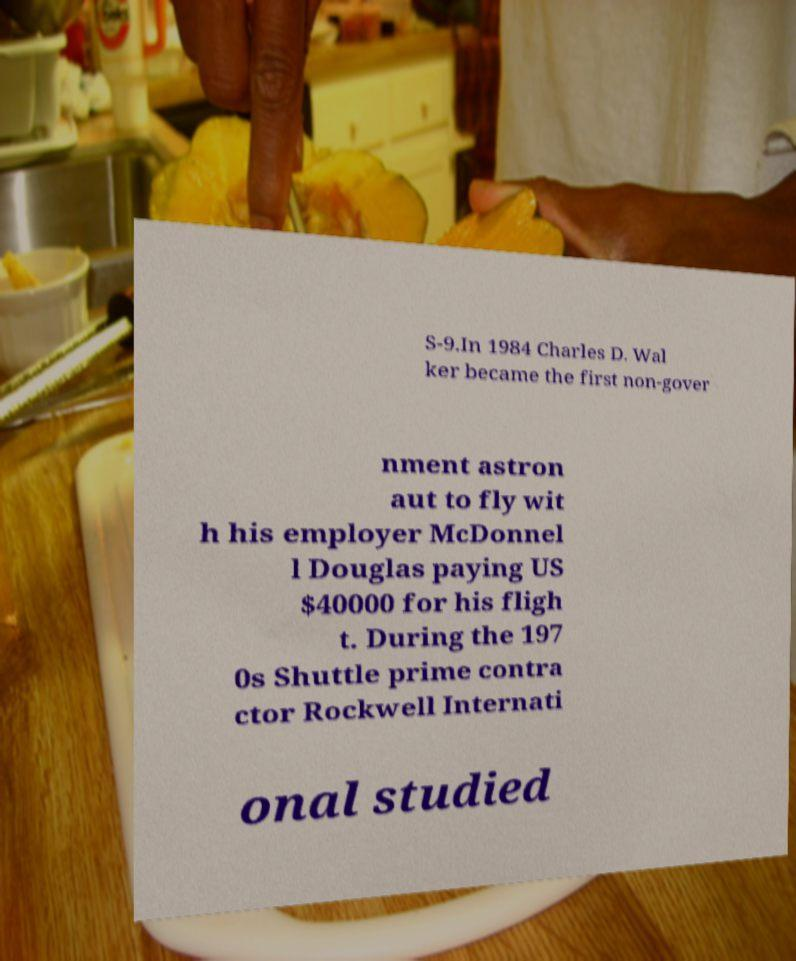I need the written content from this picture converted into text. Can you do that? S-9.In 1984 Charles D. Wal ker became the first non-gover nment astron aut to fly wit h his employer McDonnel l Douglas paying US $40000 for his fligh t. During the 197 0s Shuttle prime contra ctor Rockwell Internati onal studied 